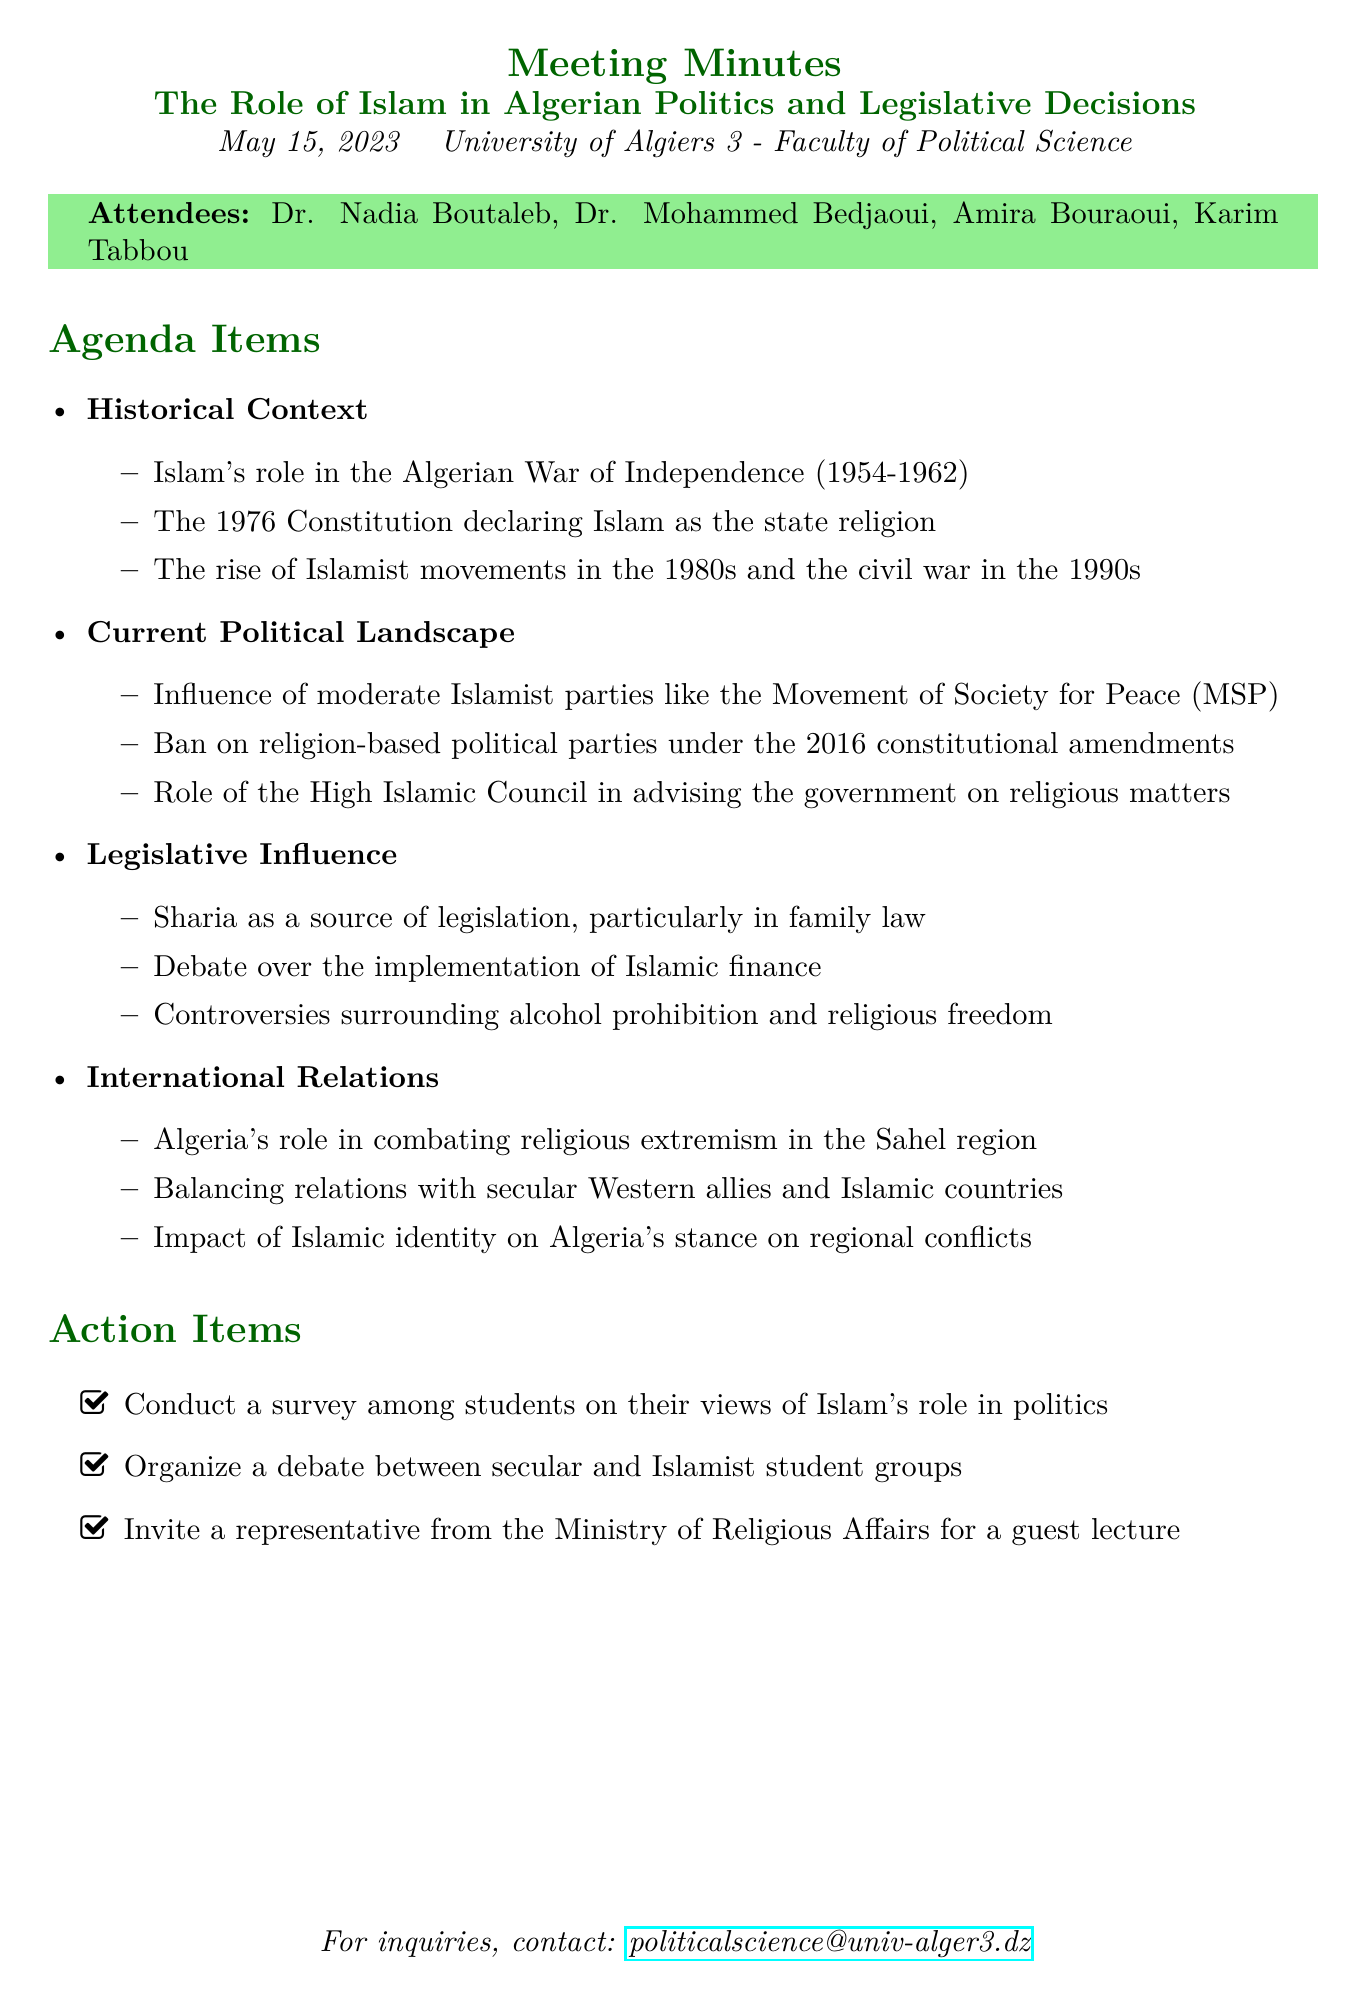What is the date of the meeting? The date of the meeting is mentioned in the document as May 15, 2023.
Answer: May 15, 2023 Who is the professor of Political Islam listed among the attendees? The document lists Dr. Nadia Boutaleb as the professor of Political Islam among the attendees.
Answer: Dr. Nadia Boutaleb What constitutional amendment banned religion-based political parties? The document states that the 2016 constitutional amendments included the ban on religion-based political parties.
Answer: 2016 What was identified as a source of legislation in family law? The document specifies Sharia as a source of legislation, particularly in family law.
Answer: Sharia What is one action item proposed at the meeting? The document lists several action items, including conducting a survey among students on their views of Islam's role in politics.
Answer: Conduct a survey Which Islamist party is mentioned in the current political landscape? The document mentions the Movement of Society for Peace (MSP) as a moderate Islamist party.
Answer: Movement of Society for Peace (MSP) What historical event was discussed in the context of Islam's role in Algeria? The document refers to Islam's role in the Algerian War of Independence (1954-1962) as a key historical context.
Answer: Algerian War of Independence (1954-1962) What does the High Islamic Council do according to the document? The document states that the High Islamic Council advises the government on religious matters.
Answer: Advising the government How does Algeria balance its international relations according to the meeting? The document mentions Algeria seeks to balance relations with secular Western allies and Islamic countries.
Answer: Secular Western allies and Islamic countries 